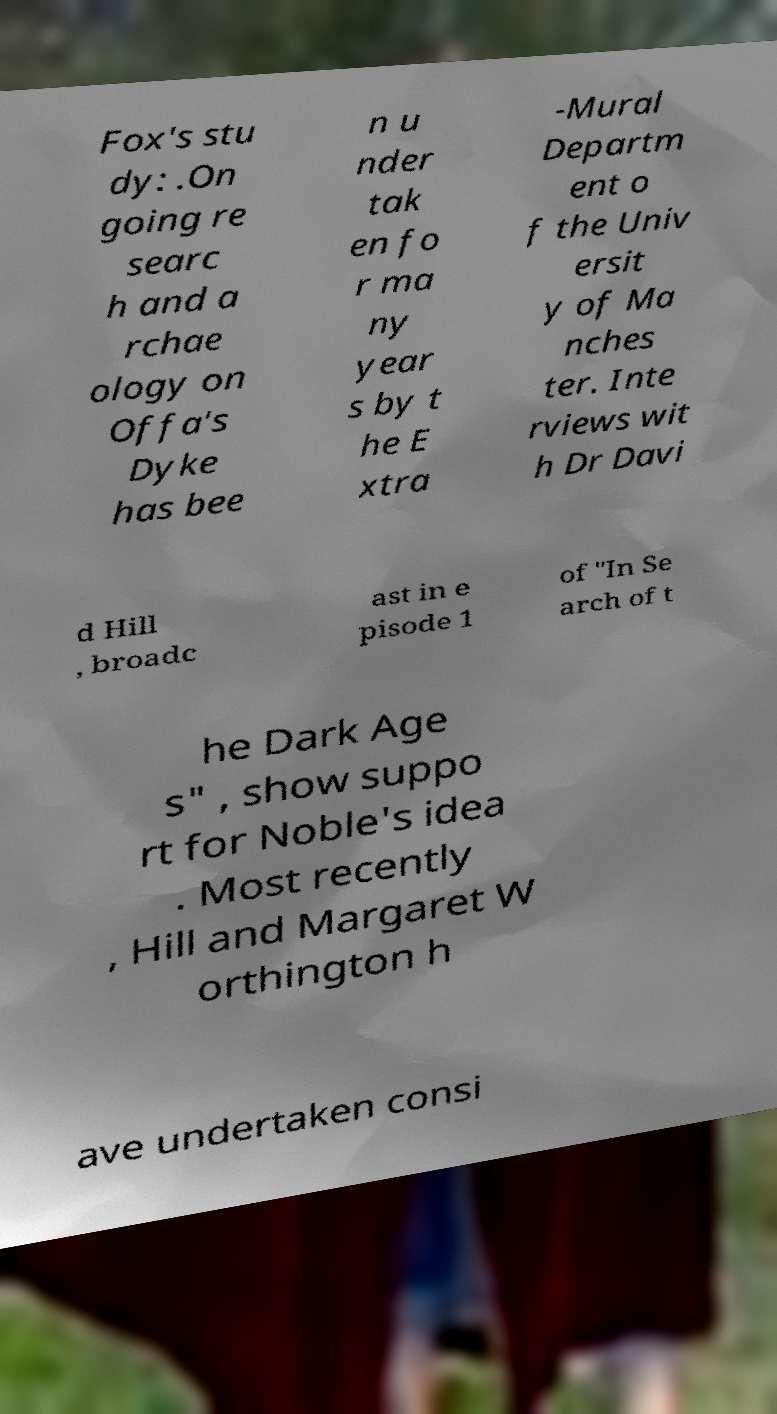Can you read and provide the text displayed in the image?This photo seems to have some interesting text. Can you extract and type it out for me? Fox's stu dy: .On going re searc h and a rchae ology on Offa's Dyke has bee n u nder tak en fo r ma ny year s by t he E xtra -Mural Departm ent o f the Univ ersit y of Ma nches ter. Inte rviews wit h Dr Davi d Hill , broadc ast in e pisode 1 of "In Se arch of t he Dark Age s" , show suppo rt for Noble's idea . Most recently , Hill and Margaret W orthington h ave undertaken consi 